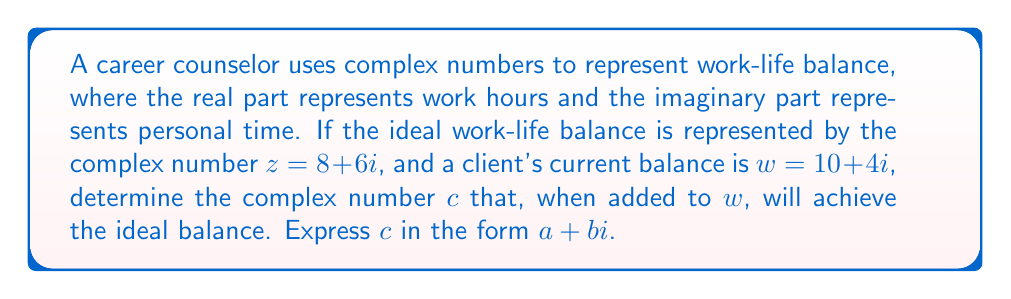Give your solution to this math problem. To solve this problem, we'll follow these steps:

1) The ideal work-life balance is represented by $z = 8 + 6i$
2) The client's current balance is $w = 10 + 4i$
3) We need to find $c$ such that $w + c = z$

Let's set up the equation:
$$(10 + 4i) + (a + bi) = 8 + 6i$$

Now, we'll separate the real and imaginary parts:

Real part: $10 + a = 8$
Imaginary part: $4 + b = 6$

Solving for $a$ and $b$:

$a = 8 - 10 = -2$
$b = 6 - 4 = 2$

Therefore, the complex number $c$ that needs to be added to $w$ to achieve the ideal balance is $c = -2 + 2i$.

This means the client needs to reduce work hours by 2 and increase personal time by 2 units to achieve the ideal work-life balance.
Answer: $c = -2 + 2i$ 